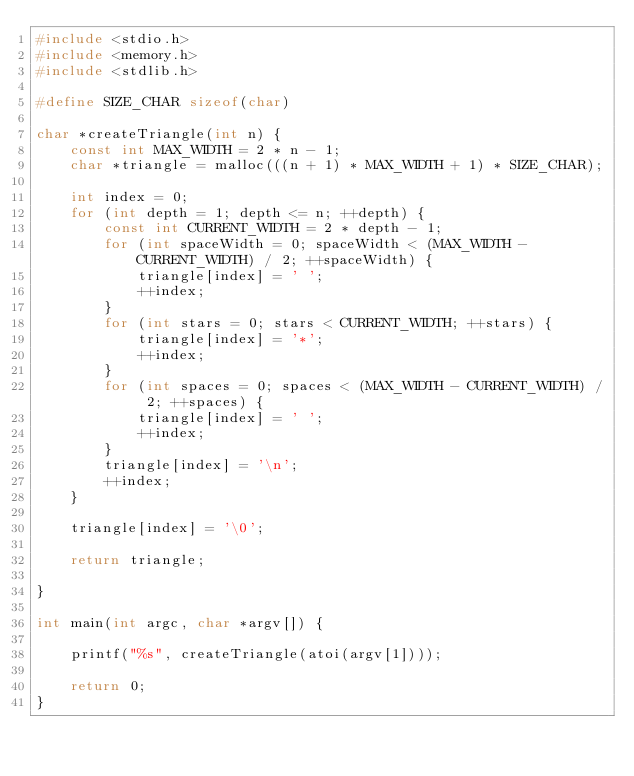<code> <loc_0><loc_0><loc_500><loc_500><_C_>#include <stdio.h>
#include <memory.h>
#include <stdlib.h>

#define SIZE_CHAR sizeof(char)

char *createTriangle(int n) {
    const int MAX_WIDTH = 2 * n - 1;
    char *triangle = malloc(((n + 1) * MAX_WIDTH + 1) * SIZE_CHAR);

    int index = 0;
    for (int depth = 1; depth <= n; ++depth) {
        const int CURRENT_WIDTH = 2 * depth - 1;
        for (int spaceWidth = 0; spaceWidth < (MAX_WIDTH - CURRENT_WIDTH) / 2; ++spaceWidth) {
            triangle[index] = ' ';
            ++index;
        }
        for (int stars = 0; stars < CURRENT_WIDTH; ++stars) {
            triangle[index] = '*';
            ++index;
        }
        for (int spaces = 0; spaces < (MAX_WIDTH - CURRENT_WIDTH) / 2; ++spaces) {
            triangle[index] = ' ';
            ++index;
        }
        triangle[index] = '\n';
        ++index;
    }

    triangle[index] = '\0';

    return triangle;

}

int main(int argc, char *argv[]) {

    printf("%s", createTriangle(atoi(argv[1])));

    return 0;
}</code> 